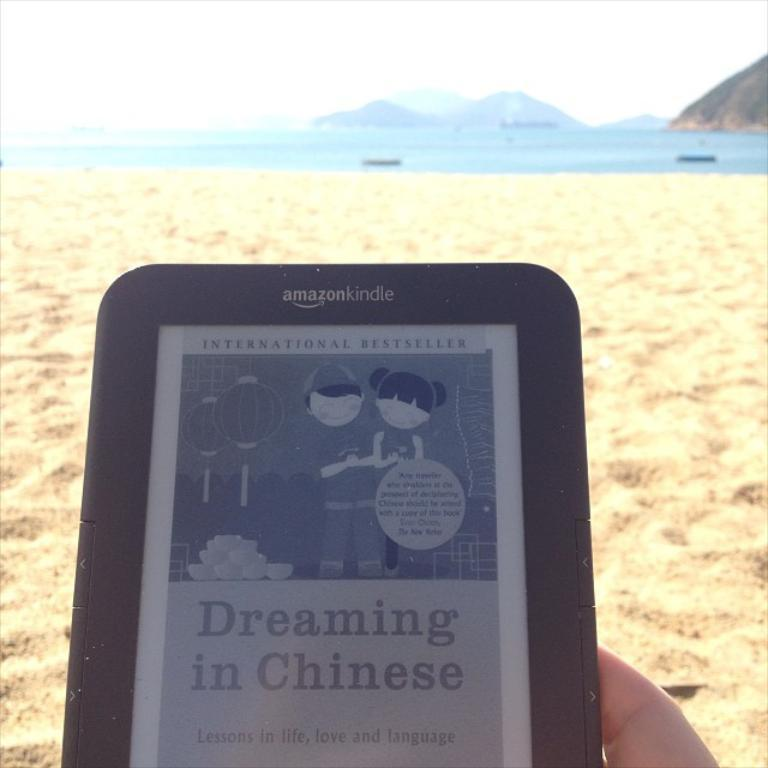What is the human hand holding in the image? There is a human hand holding a tablet in the image. What type of surface can be seen beneath the hand? There is sand visible in the image. What can be seen in the background of the image? There is water and hills in the background of the image. What is visible at the top of the image? The sky is visible at the top of the image. What type of breakfast or lunch is being served in the image? There is no food or meal visible in the image; it only shows a human hand holding a tablet. 